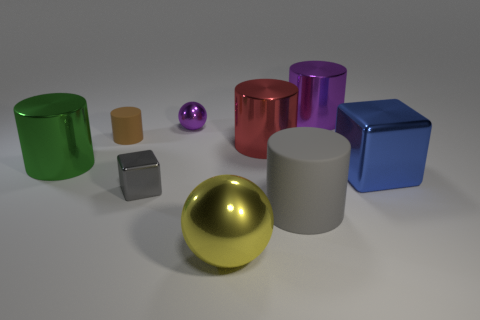Subtract all green cylinders. How many cylinders are left? 4 Subtract all green cylinders. How many cylinders are left? 4 Subtract all blue cylinders. How many yellow spheres are left? 1 Add 2 small purple things. How many small purple things are left? 3 Add 7 big green metallic objects. How many big green metallic objects exist? 8 Add 1 big purple cylinders. How many objects exist? 10 Subtract 0 red blocks. How many objects are left? 9 Subtract all balls. How many objects are left? 7 Subtract 2 cylinders. How many cylinders are left? 3 Subtract all gray cylinders. Subtract all cyan balls. How many cylinders are left? 4 